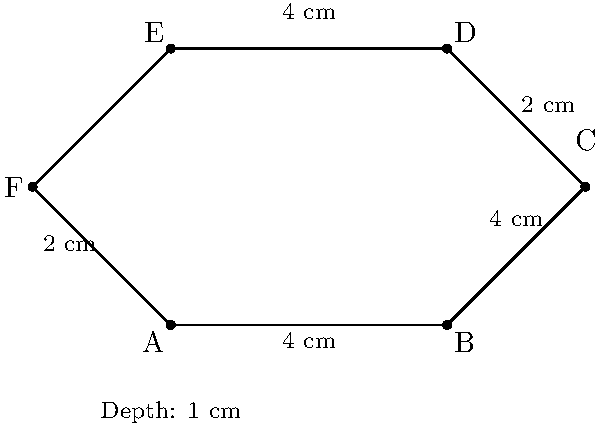You're designing a unique hexagonal bookshelf for your child's room. The shelf has the dimensions shown in the diagram, with a depth of 1 cm. Calculate the total surface area of the bookshelf, including all sides and the back panel. To calculate the total surface area, we need to find the area of each face and sum them up:

1. Front and back faces (hexagons):
   Area of hexagon = $\frac{3\sqrt{3}}{2}a^2$, where $a$ is the side length
   $a = 4$ cm
   Area of one hexagon = $\frac{3\sqrt{3}}{2} \cdot 4^2 = 24\sqrt{3}$ cm²
   Area of front and back = $2 \cdot 24\sqrt{3} = 48\sqrt{3}$ cm²

2. Side faces (rectangles):
   There are 6 rectangles, each with width 1 cm (depth) and length 4 cm
   Area of one rectangle = $4 \cdot 1 = 4$ cm²
   Area of all side faces = $6 \cdot 4 = 24$ cm²

3. Total surface area:
   $\text{Total Area} = 48\sqrt{3} + 24 = (48\sqrt{3} + 24)$ cm²
Answer: $(48\sqrt{3} + 24)$ cm² 